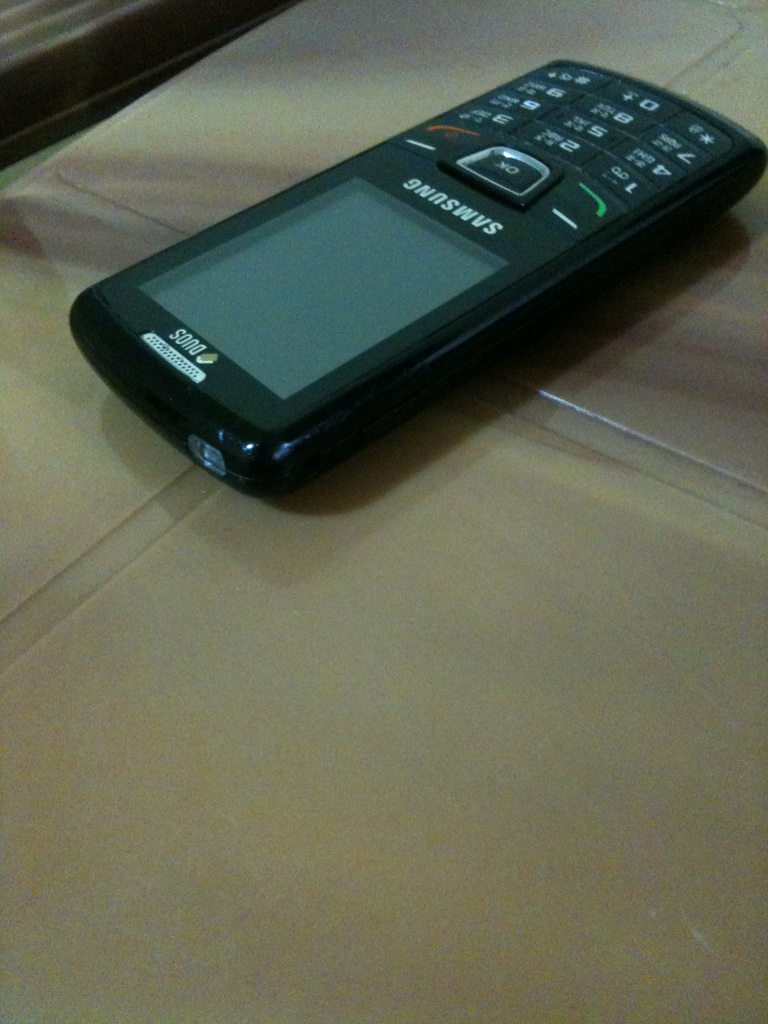How old do you think this model is? Given the design and features like physical keys, it's typical of cell phones from the late 2000s to early 2010s. 